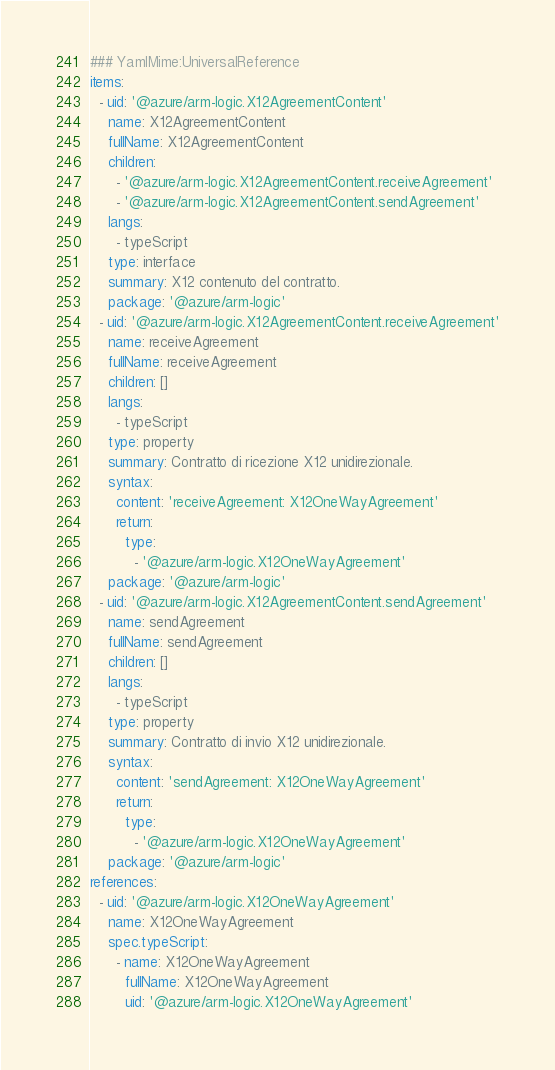<code> <loc_0><loc_0><loc_500><loc_500><_YAML_>### YamlMime:UniversalReference
items:
  - uid: '@azure/arm-logic.X12AgreementContent'
    name: X12AgreementContent
    fullName: X12AgreementContent
    children:
      - '@azure/arm-logic.X12AgreementContent.receiveAgreement'
      - '@azure/arm-logic.X12AgreementContent.sendAgreement'
    langs:
      - typeScript
    type: interface
    summary: X12 contenuto del contratto.
    package: '@azure/arm-logic'
  - uid: '@azure/arm-logic.X12AgreementContent.receiveAgreement'
    name: receiveAgreement
    fullName: receiveAgreement
    children: []
    langs:
      - typeScript
    type: property
    summary: Contratto di ricezione X12 unidirezionale.
    syntax:
      content: 'receiveAgreement: X12OneWayAgreement'
      return:
        type:
          - '@azure/arm-logic.X12OneWayAgreement'
    package: '@azure/arm-logic'
  - uid: '@azure/arm-logic.X12AgreementContent.sendAgreement'
    name: sendAgreement
    fullName: sendAgreement
    children: []
    langs:
      - typeScript
    type: property
    summary: Contratto di invio X12 unidirezionale.
    syntax:
      content: 'sendAgreement: X12OneWayAgreement'
      return:
        type:
          - '@azure/arm-logic.X12OneWayAgreement'
    package: '@azure/arm-logic'
references:
  - uid: '@azure/arm-logic.X12OneWayAgreement'
    name: X12OneWayAgreement
    spec.typeScript:
      - name: X12OneWayAgreement
        fullName: X12OneWayAgreement
        uid: '@azure/arm-logic.X12OneWayAgreement'</code> 